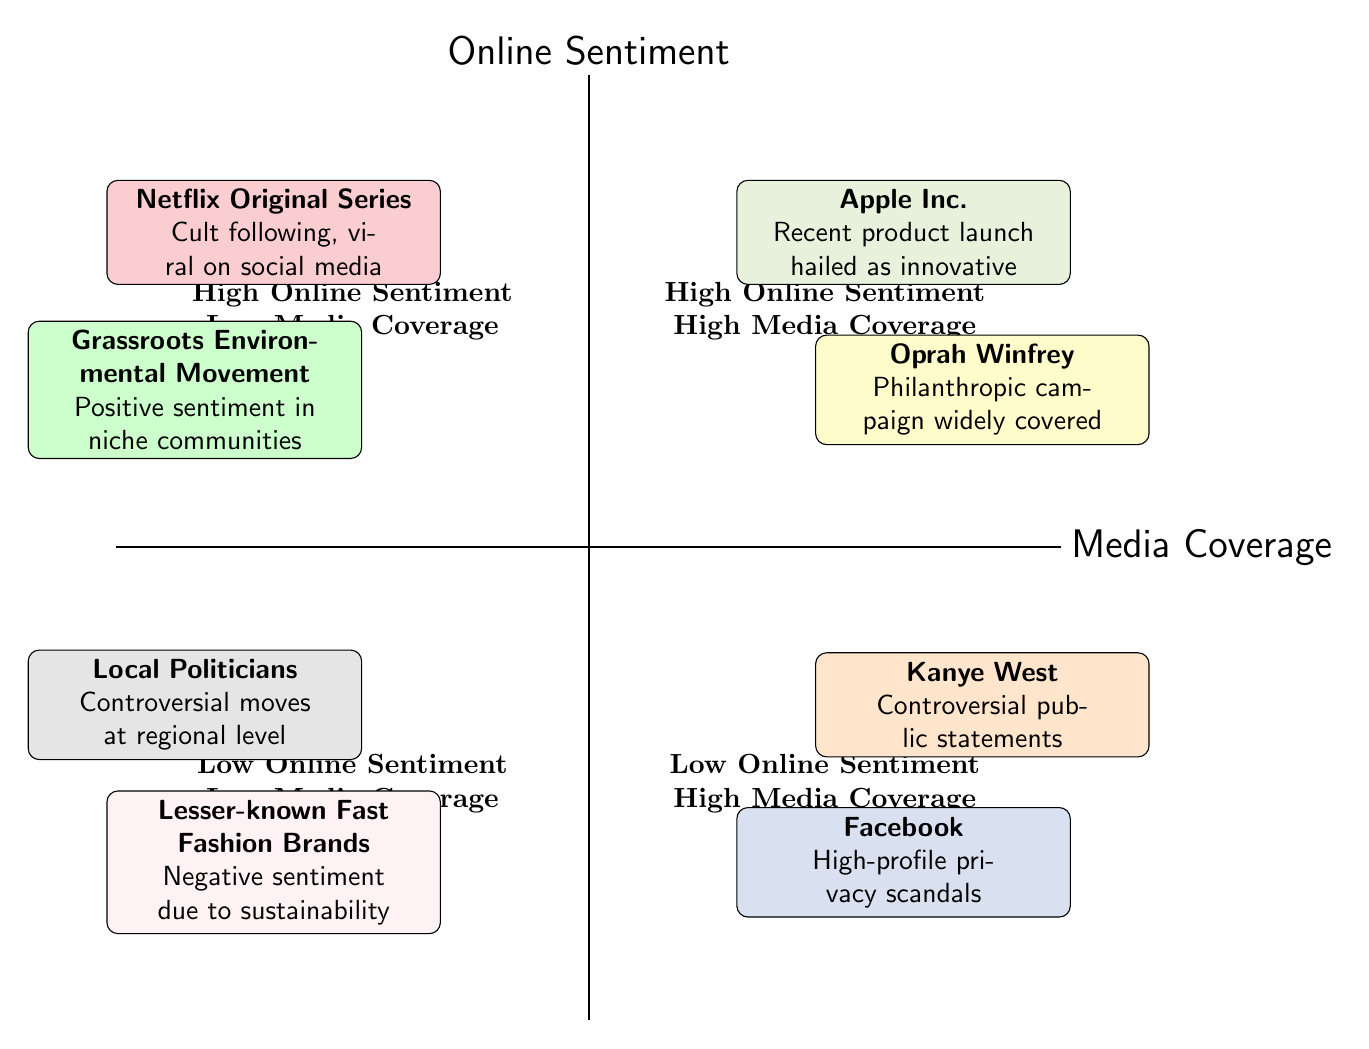What entities are in the High Online Sentiment, High Media Coverage quadrant? In the quadrant labeled "High Online Sentiment, High Media Coverage," the entities listed are Apple Inc. and Oprah Winfrey.
Answer: Apple Inc., Oprah Winfrey How many entities are in the Low Online Sentiment, Low Media Coverage quadrant? The "Low Online Sentiment, Low Media Coverage" quadrant includes two entities: Lesser-known Fast Fashion Brands and Local Politicians, which results in a total of two entities.
Answer: 2 Which entity has High Media Coverage but Low Online Sentiment? The entities with High Media Coverage and Low Online Sentiment are Facebook and Kanye West, hence both fit the criteria. However, the more specific entity queried could be any one of them; the first one listed is Facebook.
Answer: Facebook What is the sentiment for the Grassroots Environmental Movement? The Grassroots Environmental Movement is categorized under "High Online Sentiment, Low Media Coverage," indicating that it enjoys positive online sentiment.
Answer: High Which quadrant features Kanye West? Kanye West is positioned in the "Low Online Sentiment, High Media Coverage" quadrant.
Answer: Low Online Sentiment, High Media Coverage How does the online sentiment of Netflix Original Series compare to that of Lesser-known Fast Fashion Brands? Netflix Original Series enjoys High Online Sentiment in its quadrant, while Lesser-known Fast Fashion Brands have Low Online Sentiment in their quadrant, indicating a stark contrast.
Answer: Netflix Original Series has High, Lesser-known Fast Fashion Brands have Low What is a common feature of the quadrants with High Online Sentiment? Both quadrants with High Online Sentiment (High Media Coverage and Low Media Coverage) include positive reception and perceptions related to the entities therein.
Answer: Positive reception Is there any entity with Low Online Sentiment and High Media Coverage? Yes, both Facebook and Kanye West are in the Low Online Sentiment, High Media Coverage quadrant, indicating a negative sentiment despite high media attention.
Answer: Yes, Facebook and Kanye West 